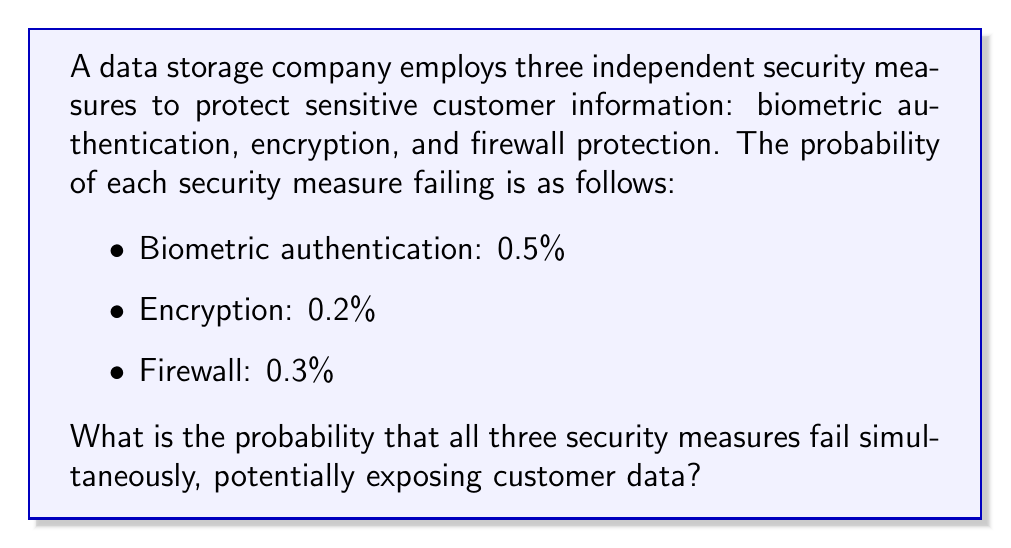Show me your answer to this math problem. To solve this problem, we need to use the concept of independent events and their probabilities.

1. First, let's convert the percentages to decimal probabilities:
   - Biometric authentication: $0.5\% = 0.005$
   - Encryption: $0.2\% = 0.002$
   - Firewall: $0.3\% = 0.003$

2. Since we want to know the probability of all three measures failing simultaneously, we need to calculate the probability of the intersection of these events.

3. For independent events, the probability of all events occurring is the product of their individual probabilities:

   $$P(A \cap B \cap C) = P(A) \times P(B) \times P(C)$$

   Where:
   $A$ is the event of biometric authentication failing
   $B$ is the event of encryption failing
   $C$ is the event of firewall failing

4. Substituting the values:

   $$P(\text{all failing}) = 0.005 \times 0.002 \times 0.003$$

5. Calculating the result:

   $$P(\text{all failing}) = 0.000000030 = 3 \times 10^{-8}$$

6. To express this as a percentage:

   $$3 \times 10^{-8} \times 100\% = 0.0000030\%$$

This extremely low probability demonstrates the effectiveness of using multiple independent security measures to protect sensitive data.
Answer: $3 \times 10^{-8}$ or $0.0000030\%$ 